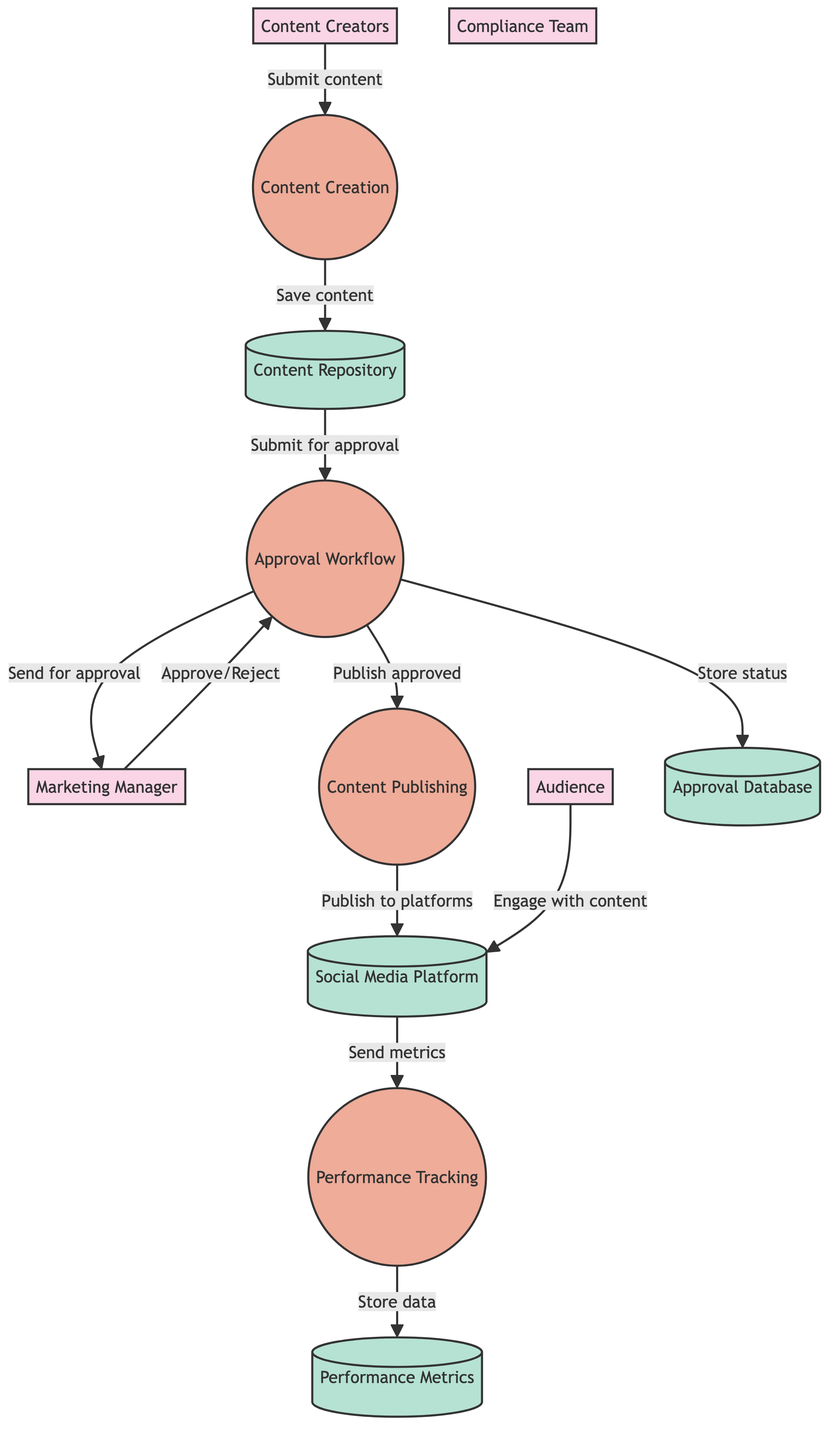What are the external entities involved in the process? The diagram shows four external entities: Content Creators, Marketing Manager, Compliance Team, and Audience.
Answer: Content Creators, Marketing Manager, Compliance Team, Audience How many processes are defined in the diagram? The diagram includes four processes: Content Creation, Approval Workflow, Content Publishing, and Performance Tracking.
Answer: Four What does the Approval Workflow process send to the Marketing Manager? The Approval Workflow sends content for final approval to the Marketing Manager.
Answer: Content for final approval Which data store contains performance data? The Performance Metrics data store is where performance data such as likes, shares, and comments are stored and tracked.
Answer: Performance Metrics What is the final action taken after the Approval Workflow? After the Approval Workflow, the final action is to publish approved content.
Answer: Publish approved content Explain the relationship between the Approval Workflow and the Approval Database. The Approval Workflow stores the approval status and history in the Approval Database, indicating that this relationship involves data storage from the workflow process to the database.
Answer: Store approval status and history Where does the Audience engage with content? The Audience engages with the published content on the Social Media Platform, indicating direct interaction with the external platform where content is displayed.
Answer: Social Media Platform How does performance data get to Performance Metrics? Performance metrics are sent from the Performance Tracking process to the Performance Metrics data store, representing the flow of collected data into the storage.
Answer: Send performance metrics What type of actions do Content Creators perform? Content Creators submit new content ideas and drafts, initiating the process of content generation in the workflow.
Answer: Submit new content ideas and drafts 